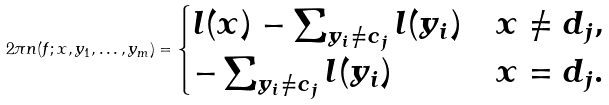<formula> <loc_0><loc_0><loc_500><loc_500>2 \pi n ( f ; x , y _ { 1 } , \dots , y _ { m } ) = \begin{cases} l ( x ) - \sum _ { y _ { i } \neq c _ { j } } l ( y _ { i } ) & x \neq d _ { j } , \\ - \sum _ { y _ { i } \neq c _ { j } } l ( y _ { i } ) & x = d _ { j } . \end{cases}</formula> 